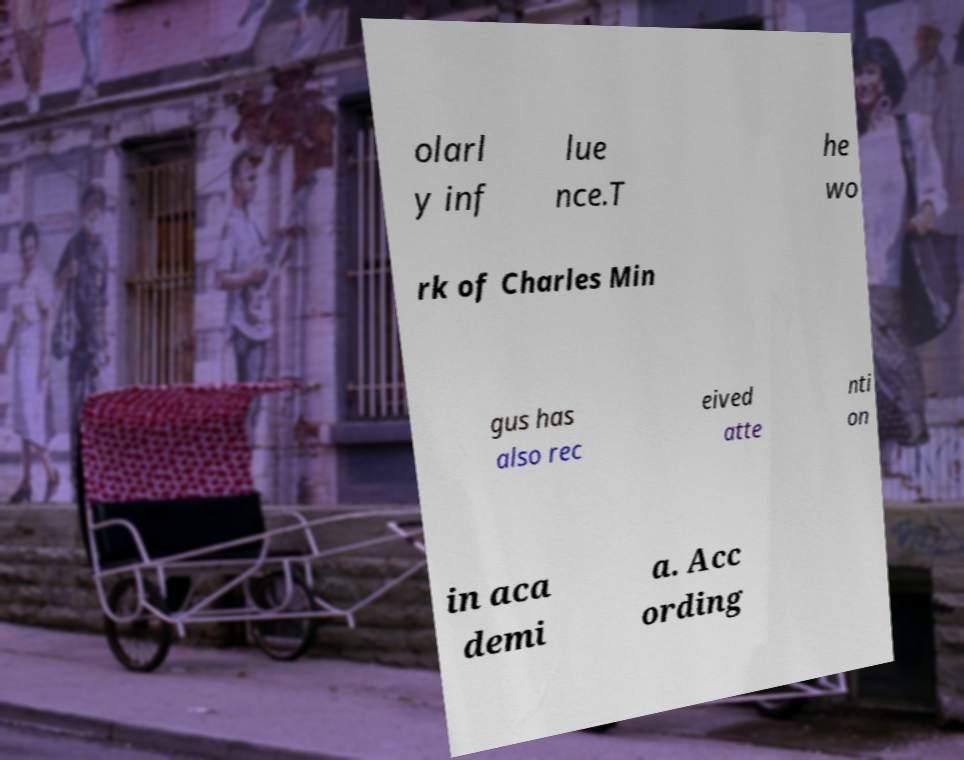Please identify and transcribe the text found in this image. olarl y inf lue nce.T he wo rk of Charles Min gus has also rec eived atte nti on in aca demi a. Acc ording 